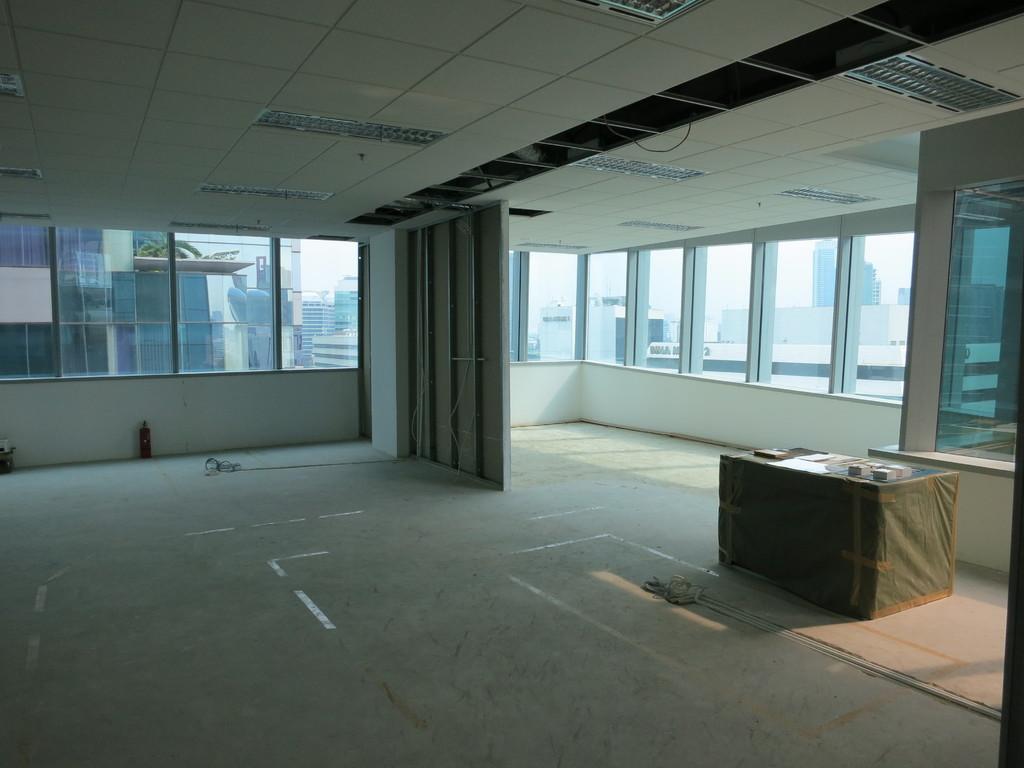Can you describe this image briefly? This image is clicked inside a room. There are windows in the middle. There are lights at the top. There is a table on the right side. 